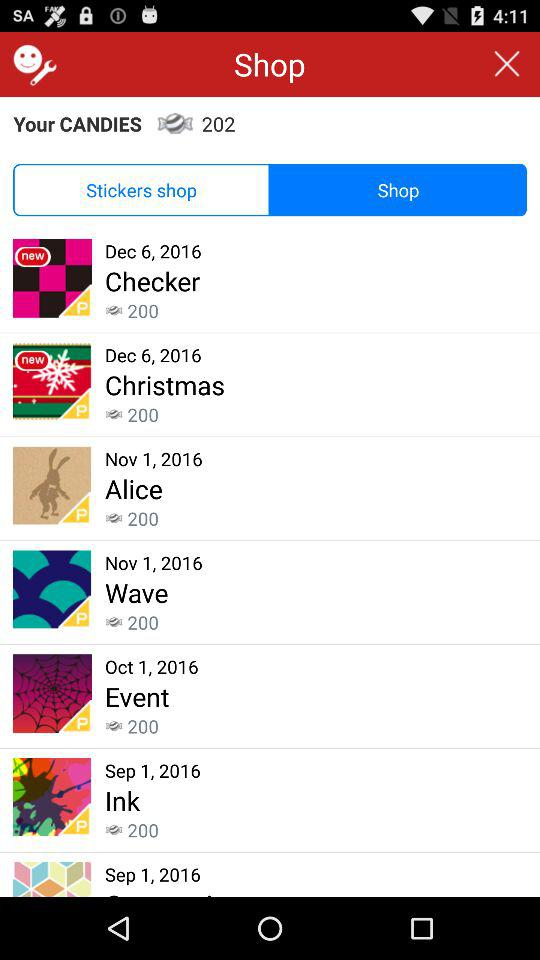How many candies are there? There are 202 candies. 